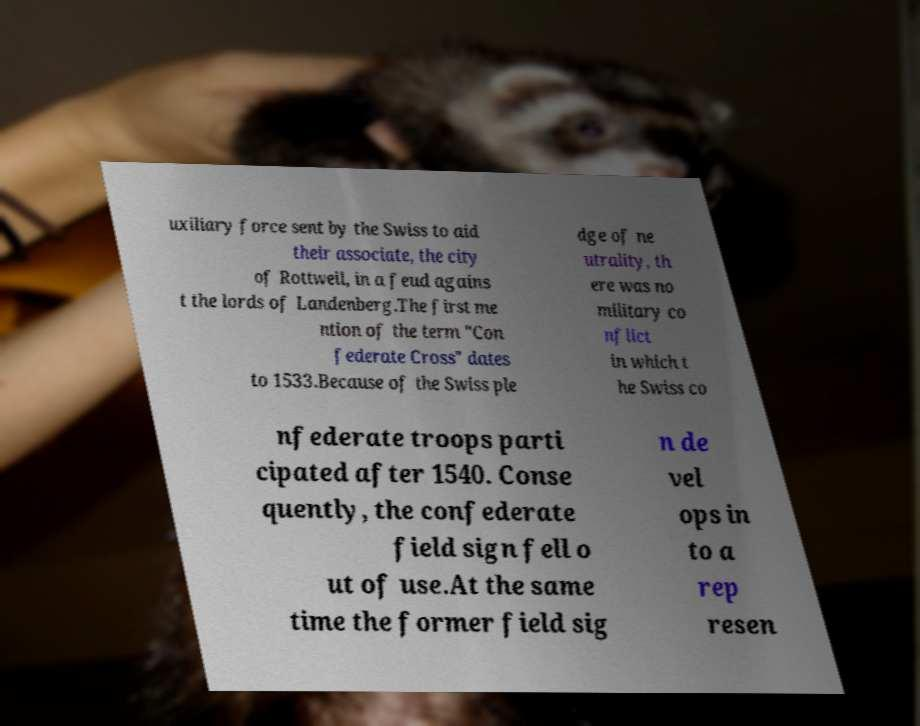For documentation purposes, I need the text within this image transcribed. Could you provide that? uxiliary force sent by the Swiss to aid their associate, the city of Rottweil, in a feud agains t the lords of Landenberg.The first me ntion of the term "Con federate Cross" dates to 1533.Because of the Swiss ple dge of ne utrality, th ere was no military co nflict in which t he Swiss co nfederate troops parti cipated after 1540. Conse quently, the confederate field sign fell o ut of use.At the same time the former field sig n de vel ops in to a rep resen 